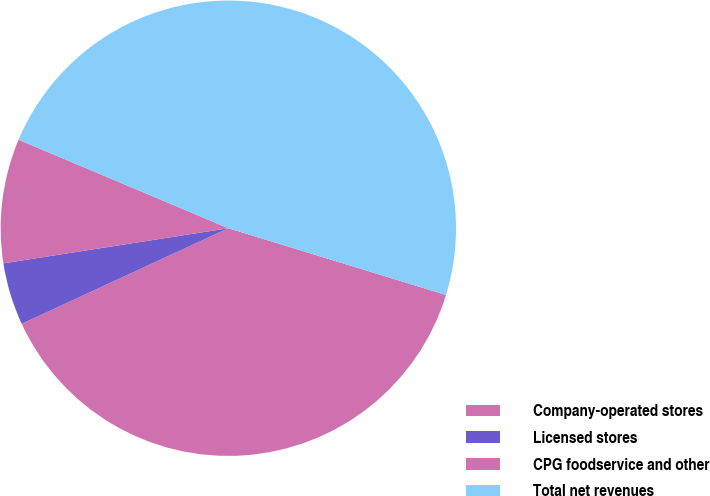Convert chart to OTSL. <chart><loc_0><loc_0><loc_500><loc_500><pie_chart><fcel>Company-operated stores<fcel>Licensed stores<fcel>CPG foodservice and other<fcel>Total net revenues<nl><fcel>38.37%<fcel>4.43%<fcel>8.82%<fcel>48.38%<nl></chart> 